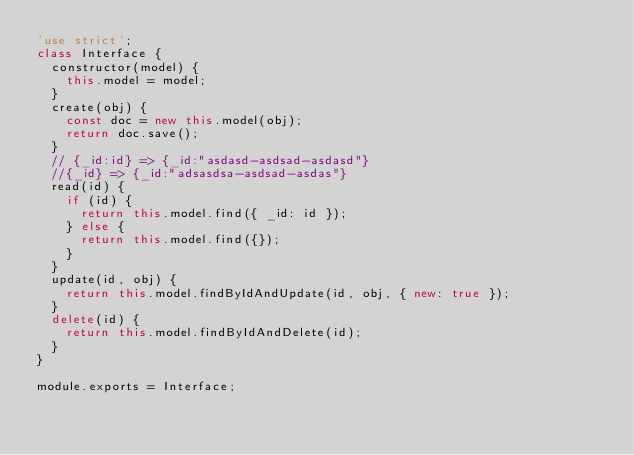Convert code to text. <code><loc_0><loc_0><loc_500><loc_500><_JavaScript_>'use strict';
class Interface {
  constructor(model) {
    this.model = model;
  }
  create(obj) {
    const doc = new this.model(obj);
    return doc.save();
  }
  // {_id:id} => {_id:"asdasd-asdsad-asdasd"}
  //{_id} => {_id:"adsasdsa-asdsad-asdas"}
  read(id) {
    if (id) {
      return this.model.find({ _id: id });
    } else {
      return this.model.find({});
    }
  }
  update(id, obj) {
    return this.model.findByIdAndUpdate(id, obj, { new: true });
  }
  delete(id) {
    return this.model.findByIdAndDelete(id);
  }
}

module.exports = Interface;</code> 